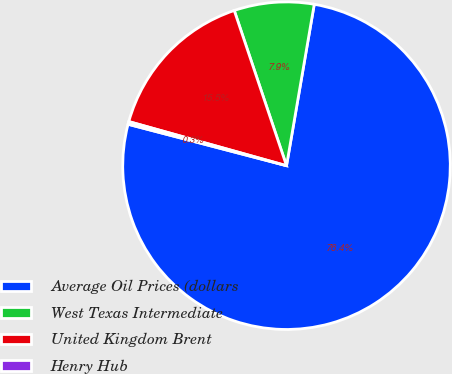<chart> <loc_0><loc_0><loc_500><loc_500><pie_chart><fcel>Average Oil Prices (dollars<fcel>West Texas Intermediate<fcel>United Kingdom Brent<fcel>Henry Hub<nl><fcel>76.37%<fcel>7.88%<fcel>15.49%<fcel>0.27%<nl></chart> 